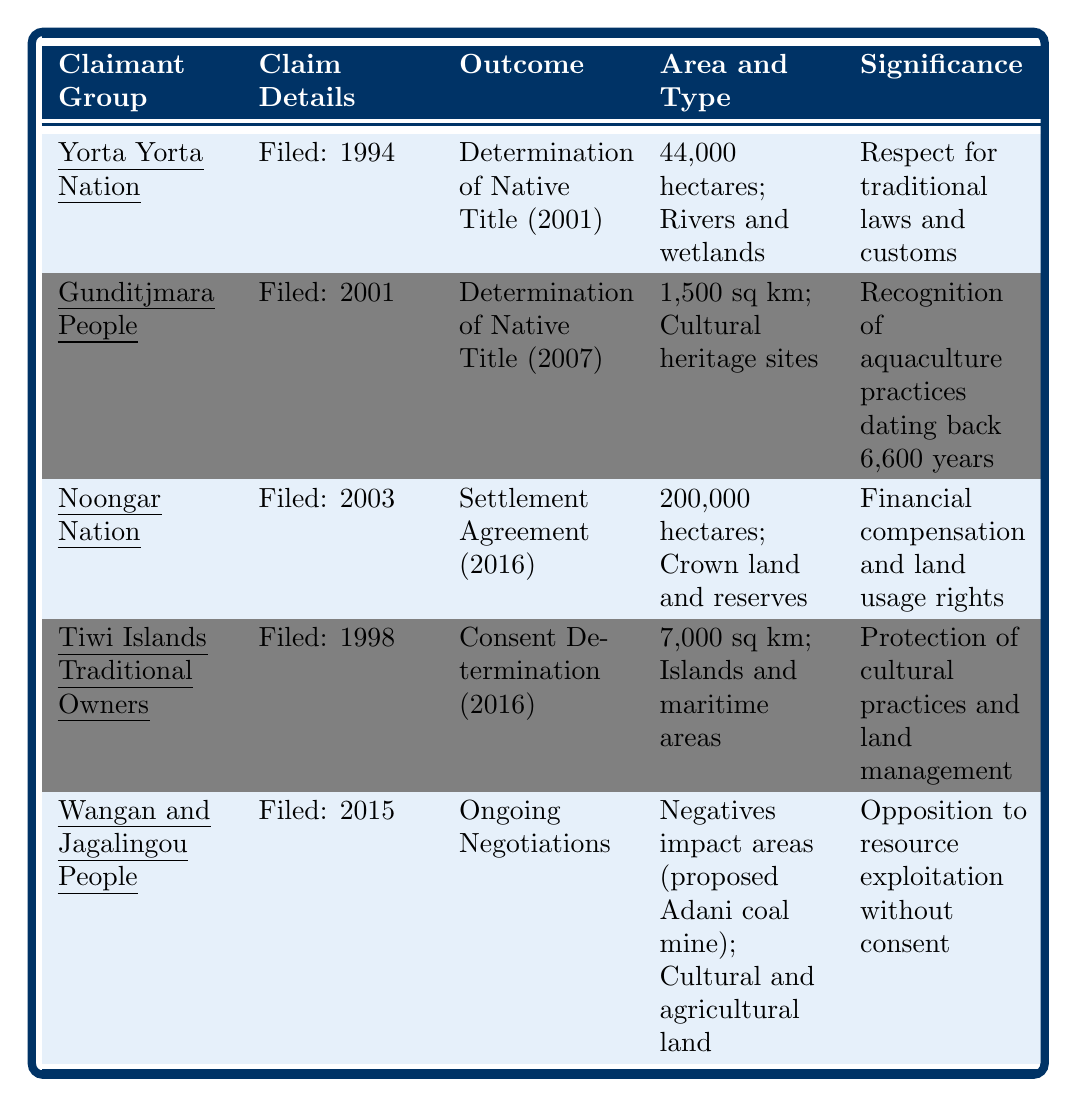What year was the claim filed by the Noongar Nation? The table shows that the Noongar Nation filed their claim in 2003, as indicated in the "yearClaimFiled" column for that group.
Answer: 2003 What is the outcome of the claim made by the Gunditjmara People? According to the table, the Gunditjmara People received a "Determination of Native Title" for their claim, as indicated in the "claimOutcome" column for that group.
Answer: Determination of Native Title How many hectares were claimed by the Yorta Yorta Nation? The table specifies that the Yorta Yorta Nation claimed "44,000 hectares," which can be found in the "areaClaimed" column for that group.
Answer: 44,000 hectares Which claimant group has its claim still under negotiations? In the table, the Wangan and Jagalingou People are listed with "Ongoing Negotiations" in the "claimOutcome" column, indicating that their claim has not yet reached a conclusion.
Answer: Wangan and Jagalingou People What type of land did the Noongar Nation claim? The table indicates that the Noongar Nation's claim involves "Crown land and reserves," as stated in the "landType" column for that group.
Answer: Crown land and reserves How many square kilometers were claimed by the Tiwi Islands Traditional Owners? The table shows that the Tiwi Islands Traditional Owners claimed "7,000 square kilometers," which is listed in the "areaClaimed" column for that group.
Answer: 7,000 square kilometers Is the outcome of the claim by the Yorta Yorta Nation a settlement agreement? According to the table, the outcome for the Yorta Yorta Nation is a "Determination of Native Title," therefore, it is not a settlement agreement.
Answer: No What is the significance of the claim by the Gunditjmara People? The table states that the significance of the Gunditjmara People's claim is "Recognition of aquaculture practices dating back 6,600 years," which is found in the "significance" column for that group.
Answer: Recognition of aquaculture practices dating back 6,600 years How does the area claimed by the Noongar Nation compare to that of the Yorta Yorta Nation? The Noongar Nation claimed "200,000 hectares," while the Yorta Yorta Nation claimed "44,000 hectares." The difference in area is calculated as 200,000 hectares - 44,000 hectares = 156,000 hectares more for the Noongar Nation.
Answer: Noongar Nation has 156,000 hectares more What is the total area claimed by both Yorta Yorta Nation and Gunditjmara People combined? To find the total area claimed, we convert the Gunditjmara People's claim to hectares: 1,500 square kilometers is equal to 150,000 hectares. Therefore, adding the areas gives us 44,000 hectares + 150,000 hectares = 194,000 hectares in total.
Answer: 194,000 hectares 